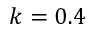Convert formula to latex. <formula><loc_0><loc_0><loc_500><loc_500>k = 0 . 4</formula> 